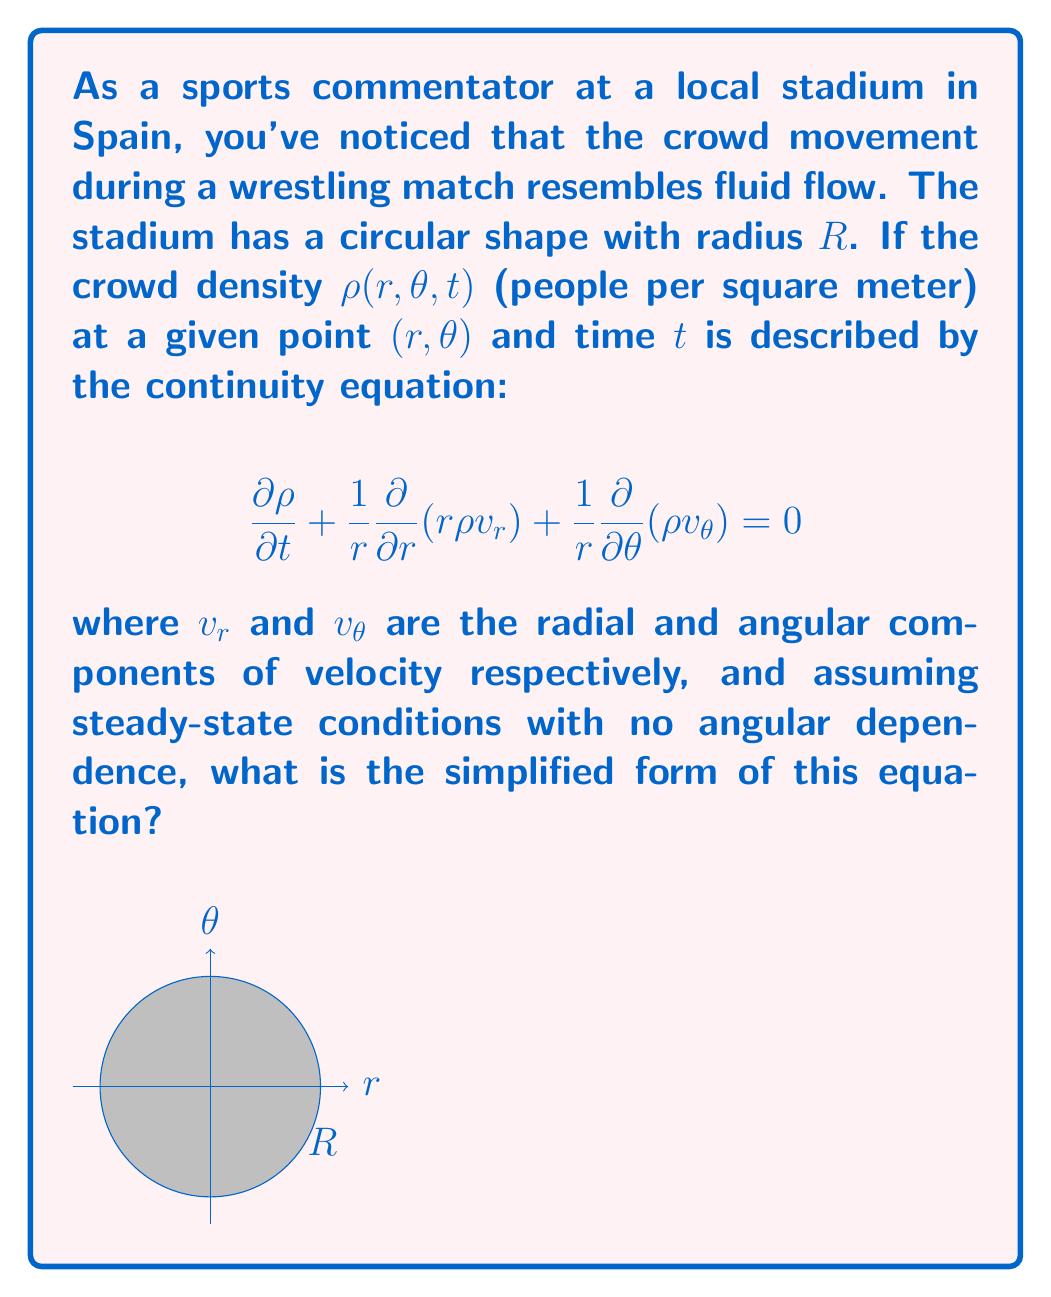Help me with this question. Let's approach this step-by-step:

1) The given continuity equation is:
   $$\frac{\partial \rho}{\partial t} + \frac{1}{r}\frac{\partial}{\partial r}(r\rho v_r) + \frac{1}{r}\frac{\partial}{\partial \theta}(\rho v_\theta) = 0$$

2) We're told to assume steady-state conditions, which means the density doesn't change with time. Therefore:
   $$\frac{\partial \rho}{\partial t} = 0$$

3) We're also told there's no angular dependence, which means:
   $$\frac{\partial}{\partial \theta}(\rho v_\theta) = 0$$

4) Applying these conditions to our original equation, we're left with:
   $$\frac{1}{r}\frac{\partial}{\partial r}(r\rho v_r) = 0$$

5) We can simplify this further by multiplying both sides by $r$:
   $$\frac{\partial}{\partial r}(r\rho v_r) = 0$$

6) This is our final, simplified form of the continuity equation under the given conditions.
Answer: $$\frac{\partial}{\partial r}(r\rho v_r) = 0$$ 